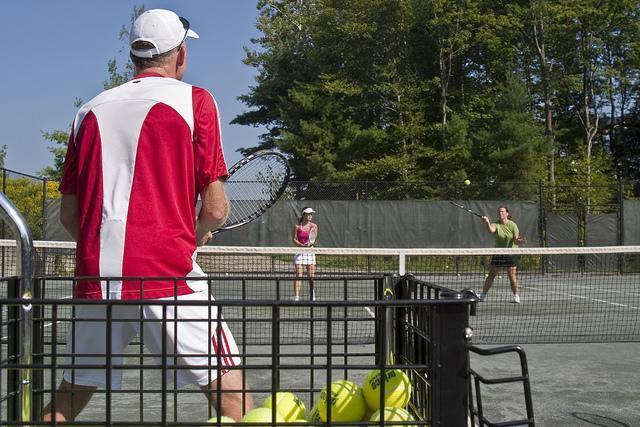How many people are in the photo?
Give a very brief answer. 2. How many cars are to the left of the bus?
Give a very brief answer. 0. 